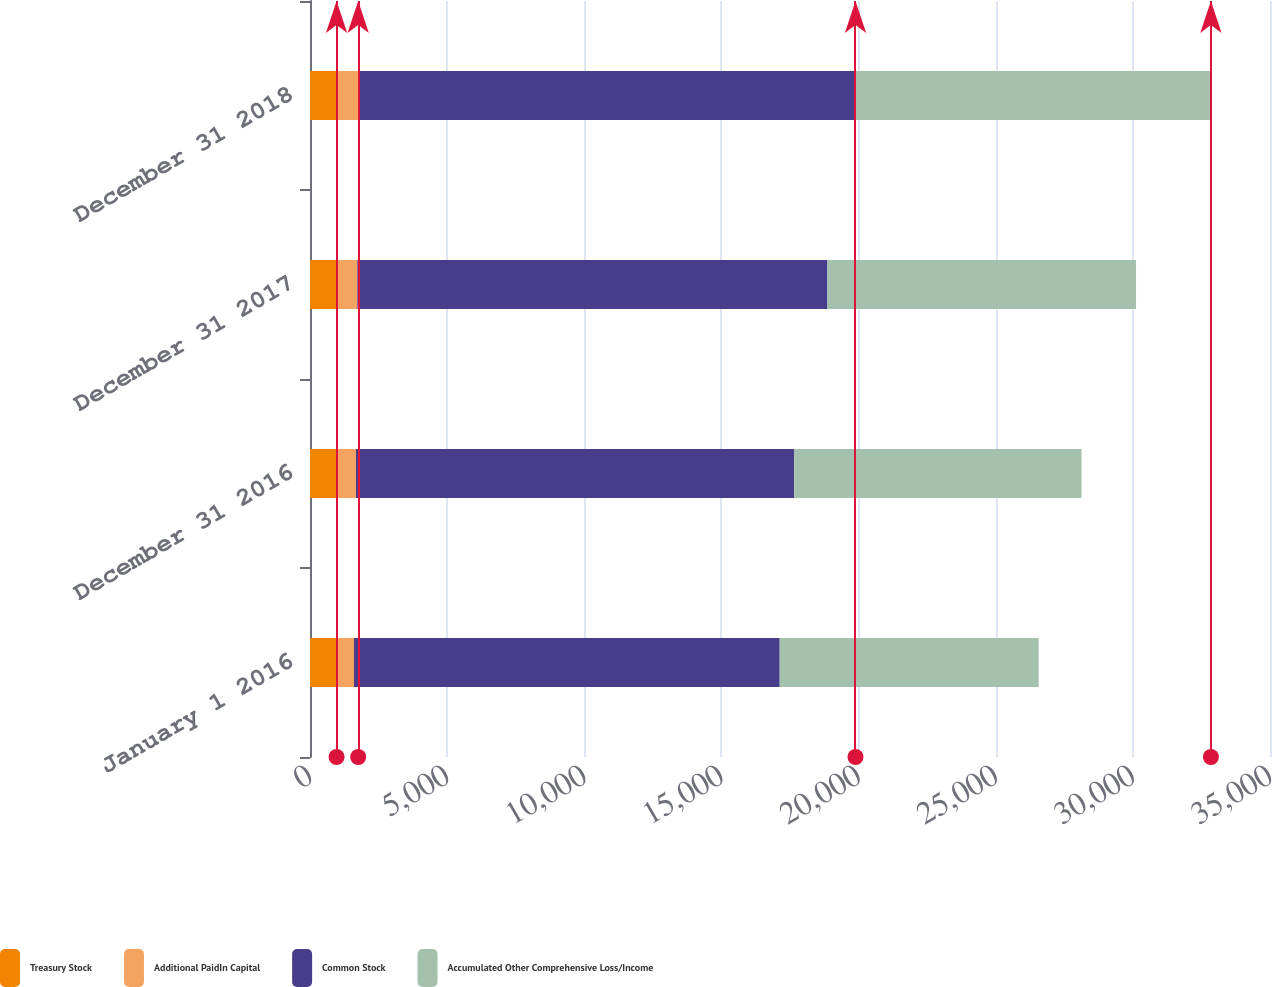Convert chart to OTSL. <chart><loc_0><loc_0><loc_500><loc_500><stacked_bar_chart><ecel><fcel>January 1 2016<fcel>December 31 2016<fcel>December 31 2017<fcel>December 31 2018<nl><fcel>Treasury Stock<fcel>969<fcel>969<fcel>969<fcel>969<nl><fcel>Additional PaidIn Capital<fcel>635<fcel>707<fcel>756<fcel>788<nl><fcel>Common Stock<fcel>15521<fcel>15980<fcel>17140<fcel>18131<nl><fcel>Accumulated Other Comprehensive Loss/Income<fcel>9440<fcel>10472<fcel>11251<fcel>12958<nl></chart> 